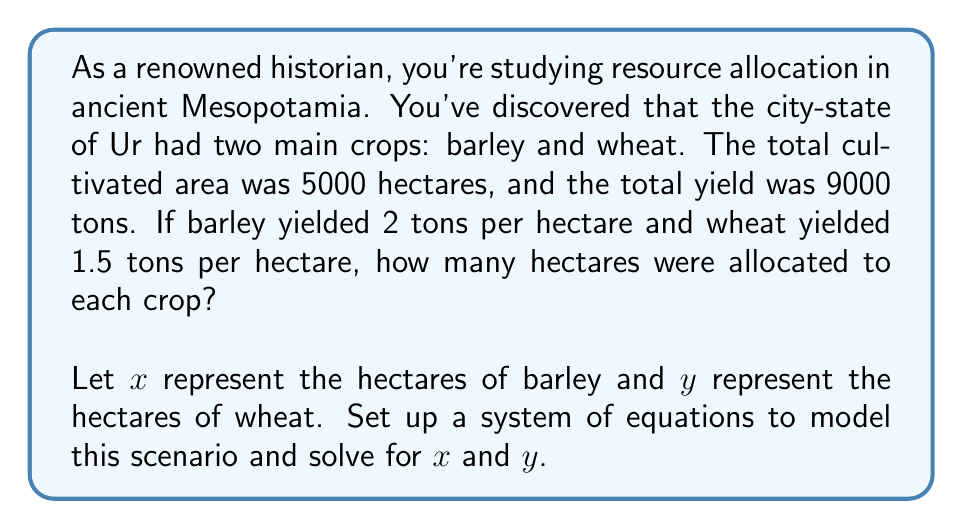Help me with this question. To solve this problem, we need to set up a system of two equations based on the given information:

1. Total area equation:
   $x + y = 5000$ (total cultivated area in hectares)

2. Total yield equation:
   $2x + 1.5y = 9000$ (total yield in tons)

Now, let's solve this system of equations using the substitution method:

1. From the first equation, express $y$ in terms of $x$:
   $y = 5000 - x$

2. Substitute this expression for $y$ into the second equation:
   $2x + 1.5(5000 - x) = 9000$

3. Simplify:
   $2x + 7500 - 1.5x = 9000$
   $0.5x + 7500 = 9000$

4. Subtract 7500 from both sides:
   $0.5x = 1500$

5. Multiply both sides by 2:
   $x = 3000$

6. Now that we know $x$, we can find $y$ using the first equation:
   $y = 5000 - x = 5000 - 3000 = 2000$

Therefore, 3000 hectares were allocated to barley and 2000 hectares to wheat.

To verify:
- Total area: $3000 + 2000 = 5000$ hectares (✓)
- Total yield: $(2 \times 3000) + (1.5 \times 2000) = 6000 + 3000 = 9000$ tons (✓)
Answer: Barley: 3000 hectares
Wheat: 2000 hectares 